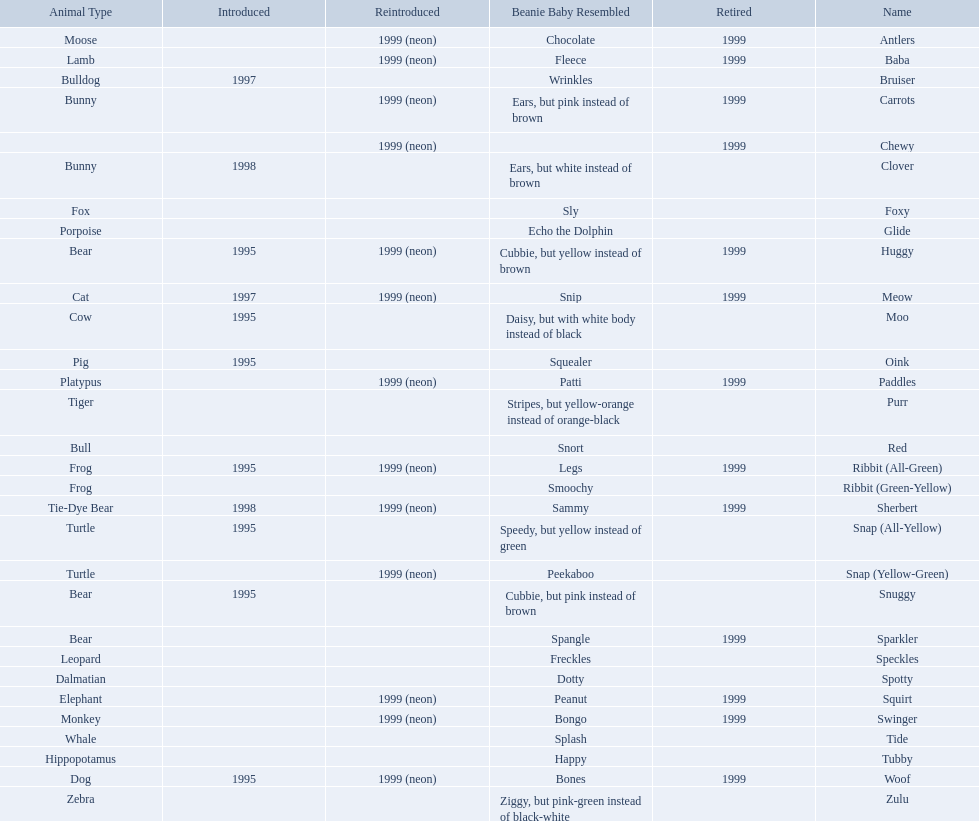Which of the listed pillow pals lack information in at least 3 categories? Chewy, Foxy, Glide, Purr, Red, Ribbit (Green-Yellow), Speckles, Spotty, Tide, Tubby, Zulu. Of those, which one lacks information in the animal type category? Chewy. 